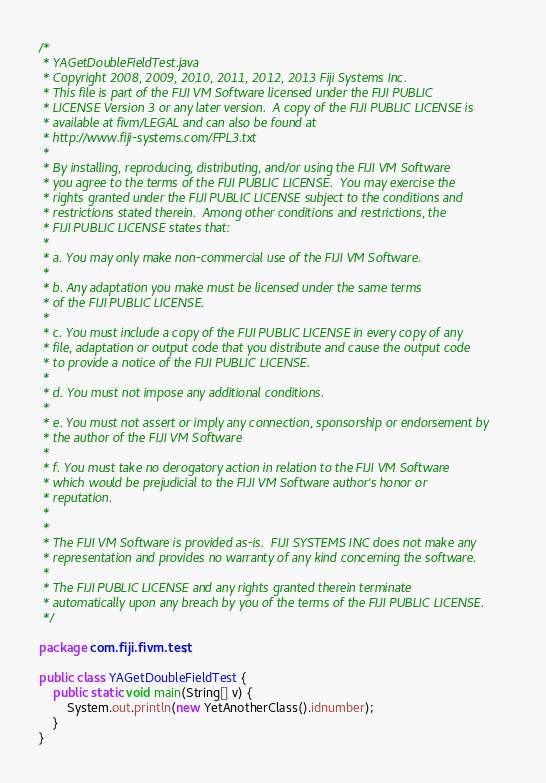<code> <loc_0><loc_0><loc_500><loc_500><_Java_>/*
 * YAGetDoubleFieldTest.java
 * Copyright 2008, 2009, 2010, 2011, 2012, 2013 Fiji Systems Inc.
 * This file is part of the FIJI VM Software licensed under the FIJI PUBLIC
 * LICENSE Version 3 or any later version.  A copy of the FIJI PUBLIC LICENSE is
 * available at fivm/LEGAL and can also be found at
 * http://www.fiji-systems.com/FPL3.txt
 * 
 * By installing, reproducing, distributing, and/or using the FIJI VM Software
 * you agree to the terms of the FIJI PUBLIC LICENSE.  You may exercise the
 * rights granted under the FIJI PUBLIC LICENSE subject to the conditions and
 * restrictions stated therein.  Among other conditions and restrictions, the
 * FIJI PUBLIC LICENSE states that:
 * 
 * a. You may only make non-commercial use of the FIJI VM Software.
 * 
 * b. Any adaptation you make must be licensed under the same terms 
 * of the FIJI PUBLIC LICENSE.
 * 
 * c. You must include a copy of the FIJI PUBLIC LICENSE in every copy of any
 * file, adaptation or output code that you distribute and cause the output code
 * to provide a notice of the FIJI PUBLIC LICENSE. 
 * 
 * d. You must not impose any additional conditions.
 * 
 * e. You must not assert or imply any connection, sponsorship or endorsement by
 * the author of the FIJI VM Software
 * 
 * f. You must take no derogatory action in relation to the FIJI VM Software
 * which would be prejudicial to the FIJI VM Software author's honor or
 * reputation.
 * 
 * 
 * The FIJI VM Software is provided as-is.  FIJI SYSTEMS INC does not make any
 * representation and provides no warranty of any kind concerning the software.
 * 
 * The FIJI PUBLIC LICENSE and any rights granted therein terminate
 * automatically upon any breach by you of the terms of the FIJI PUBLIC LICENSE.
 */

package com.fiji.fivm.test;

public class YAGetDoubleFieldTest {
    public static void main(String[] v) {
        System.out.println(new YetAnotherClass().idnumber);
    }
}

</code> 